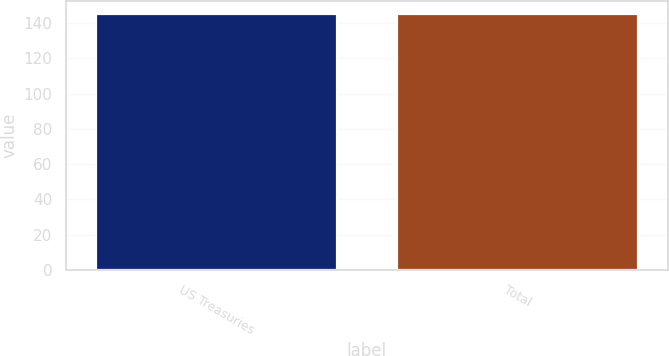Convert chart. <chart><loc_0><loc_0><loc_500><loc_500><bar_chart><fcel>US Treasuries<fcel>Total<nl><fcel>145<fcel>145.1<nl></chart> 